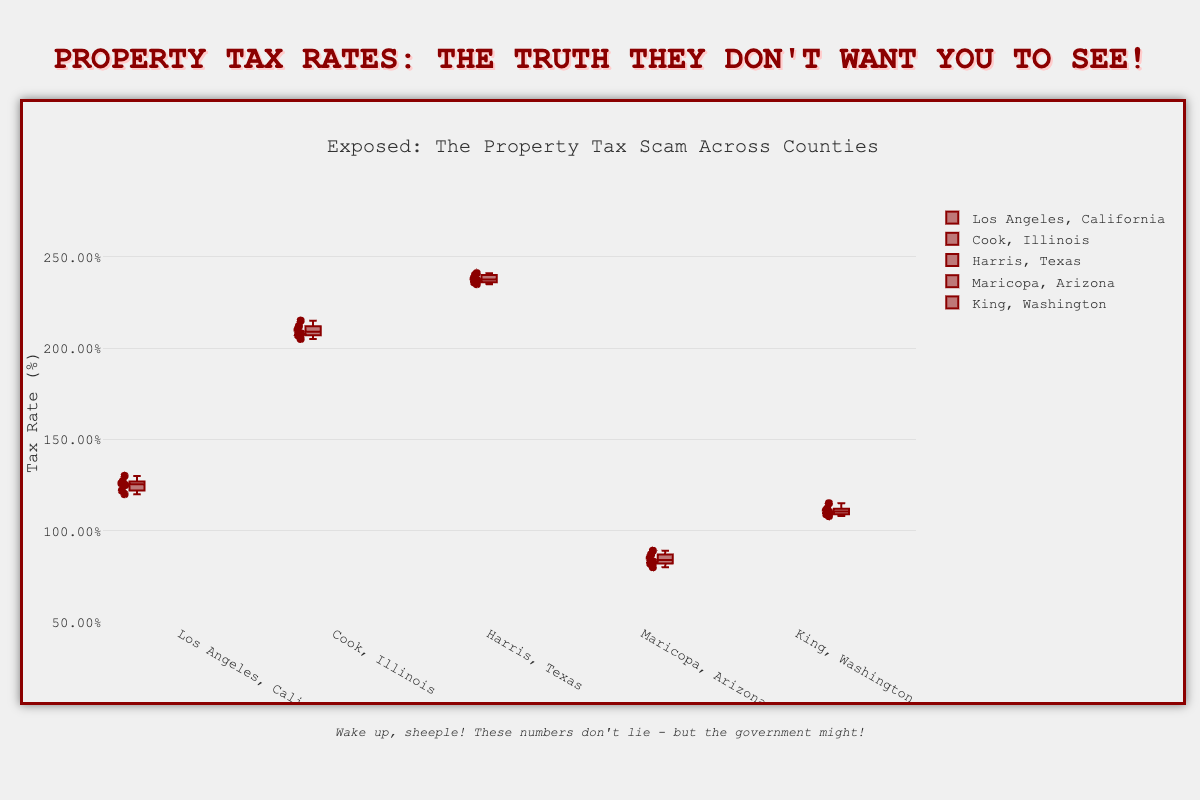What is the title of the figure? The title is located at the top of the figure, clearly displaying the heading.
Answer: Exposed: The Property Tax Scam Across Counties What is the tax rate range on the y-axis? The y-axis shows the range of tax rates. The minimum value is 0.5%, and the maximum value is 2.8%.
Answer: 0.5% to 2.8% Which county has the highest maximum tax rate? The figure shows that the highest whisker reaches the highest point for Harris County, Texas.
Answer: Harris County, Texas What is the median tax rate for Cook County, Illinois? The median is the line inside the box. For Cook County, it's between 2.10% and 2.12%.
Answer: Approximately 2.10% to 2.12% Compare the median tax rates of Los Angeles, California, and Maricopa, Arizona. Which one is higher? The figure shows that the median line in the box for Los Angeles is higher than that for Maricopa.
Answer: Los Angeles, California Which county has the lowest variation in tax rates? The box with the smallest interquartile range (IQR) indicates the lowest variation. King County, Washington, has a smaller IQR compared to others.
Answer: King County, Washington How many data points are plotted for each county? Each set of box plots has small points indicating individual data points. Each county has 6 data points.
Answer: 6 data points What's the interquartile range for Maricopa, Arizona? The interquartile range is the range within the box, from the bottom (Q1) to the top (Q3). Approximate Q1 is 0.82% and Q3 is 0.87%, so IQR = 0.87% - 0.82%.
Answer: 0.05% Between Los Angeles, California, and Harris County, Texas, which has a wider interquartile range (IQR)? Comparing the boxes of Los Angeles and Harris, Harris County has a visibly wider IQR.
Answer: Harris County, Texas Between Cook County, Illinois, and King County, Washington, which has a higher overall tax rate? The positions of the entire box plots for Cook County are higher on the y-axis compared to King County.
Answer: Cook County, Illinois 